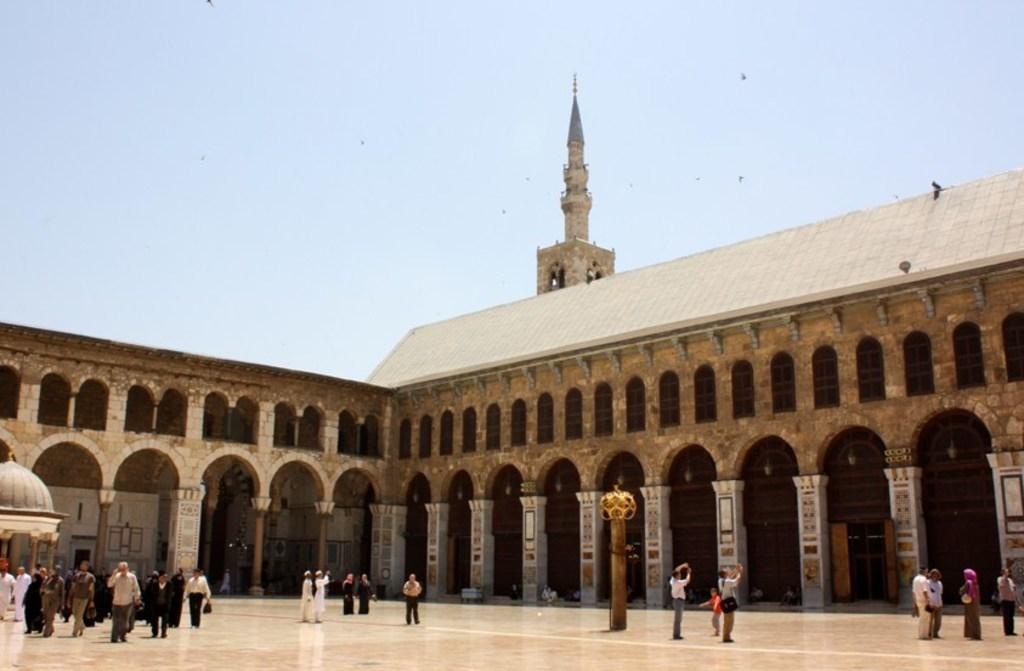What are the people in the image doing? The people in the image are on a path. What structure can be seen in the image? There is a building visible in the image. Can you describe the building in the image? Some parts of the building are visible in the image. What is happening in the sky in the image? Birds are flying in the sky in the image. Where can the people exchange their tickets in the image? There is no mention of tickets or an exchange in the image; it only shows people on a path, a building, and birds flying in the sky. 